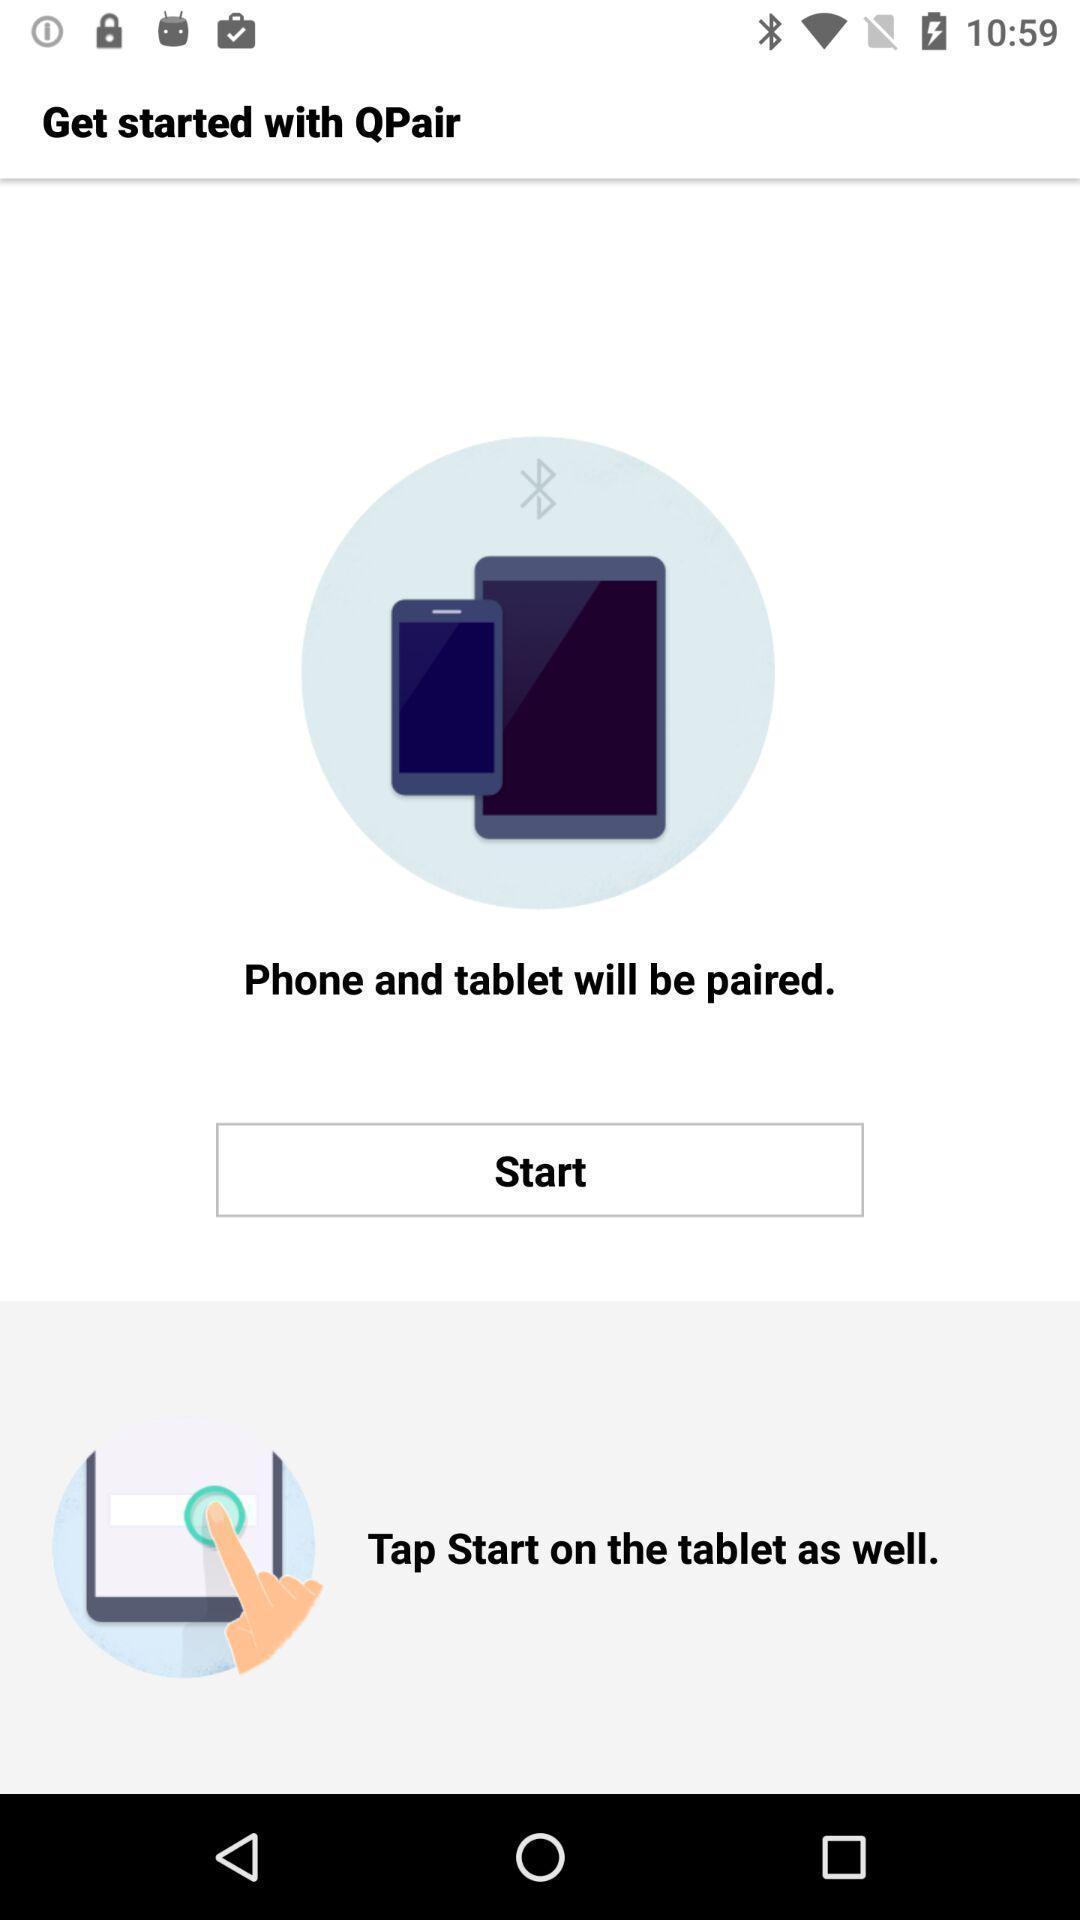Provide a textual representation of this image. Page displaying to start pairing device. 